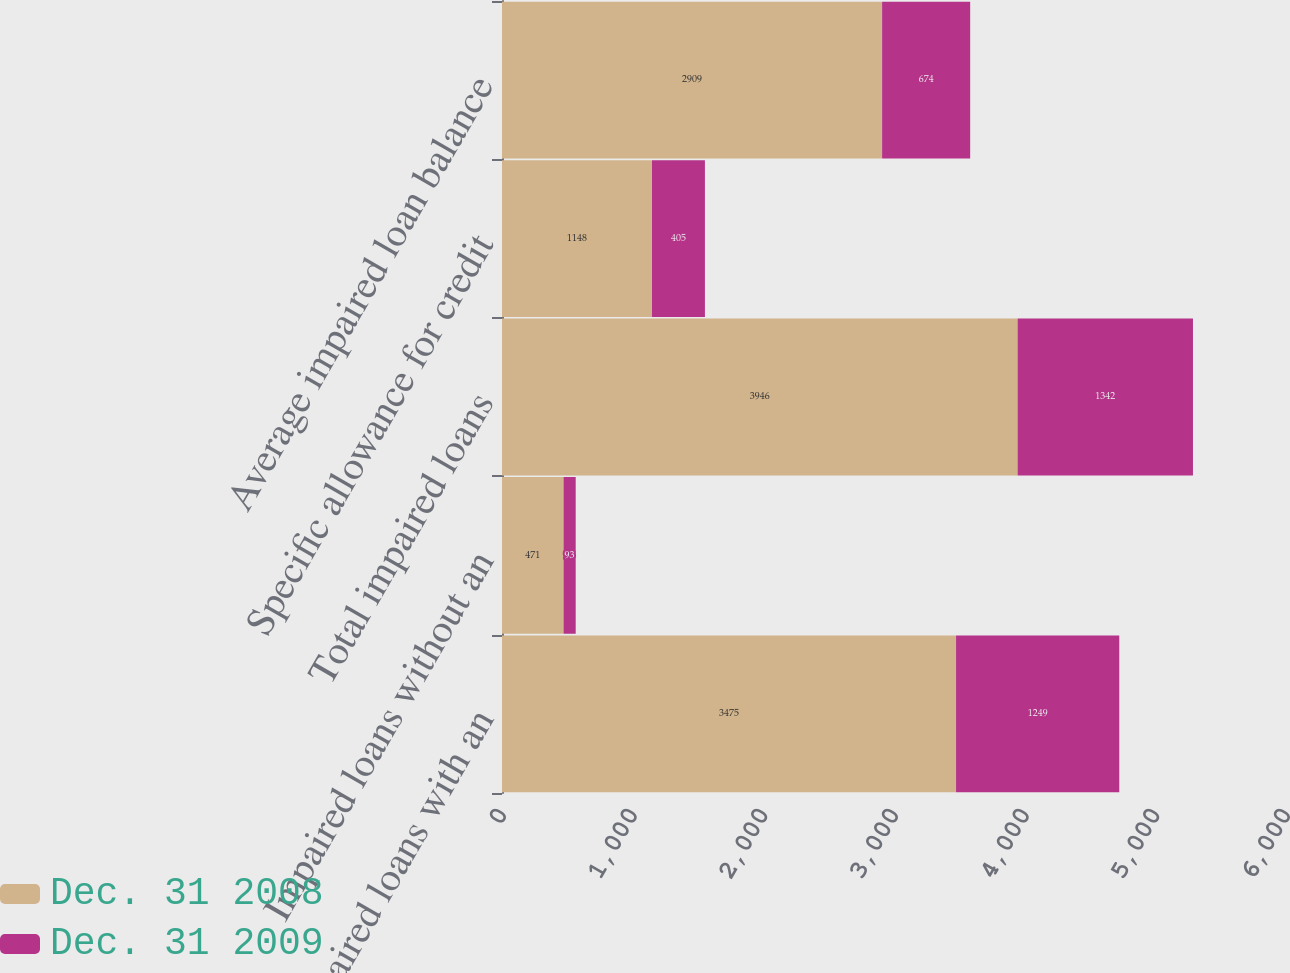Convert chart to OTSL. <chart><loc_0><loc_0><loc_500><loc_500><stacked_bar_chart><ecel><fcel>Impaired loans with an<fcel>Impaired loans without an<fcel>Total impaired loans<fcel>Specific allowance for credit<fcel>Average impaired loan balance<nl><fcel>Dec. 31 2008<fcel>3475<fcel>471<fcel>3946<fcel>1148<fcel>2909<nl><fcel>Dec. 31 2009<fcel>1249<fcel>93<fcel>1342<fcel>405<fcel>674<nl></chart> 